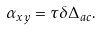<formula> <loc_0><loc_0><loc_500><loc_500>\alpha _ { x y } = \tau \delta \Delta _ { a c } .</formula> 